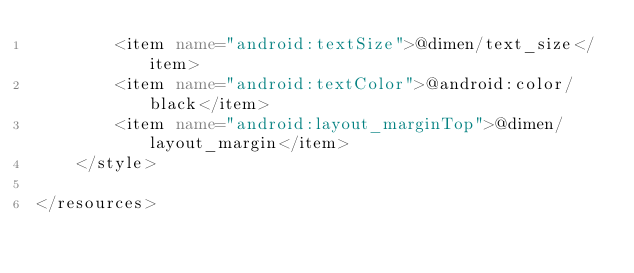<code> <loc_0><loc_0><loc_500><loc_500><_XML_>        <item name="android:textSize">@dimen/text_size</item>
        <item name="android:textColor">@android:color/black</item>
        <item name="android:layout_marginTop">@dimen/layout_margin</item>
    </style>

</resources></code> 